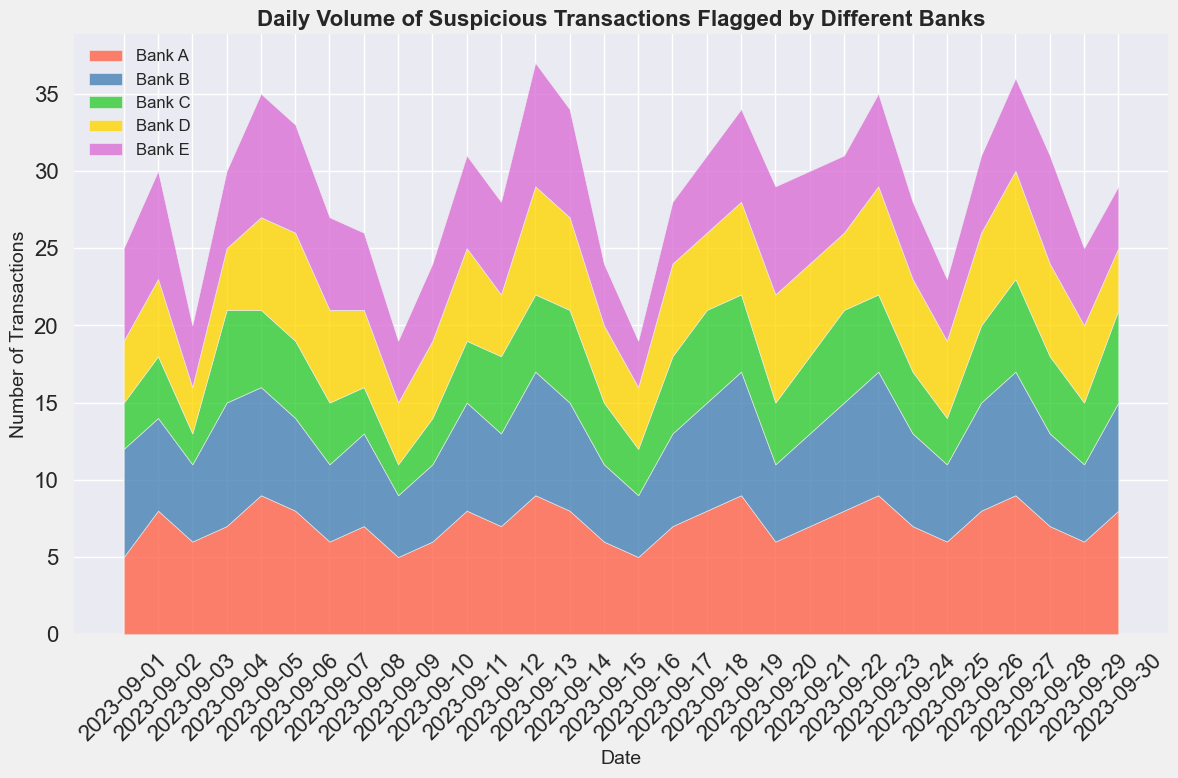What day did Bank C flag the highest number of suspicious transactions? Look at the area chart and identify the highest peak for Bank C, which corresponds to the tallest green section. Cross-reference this peak with the date on the x-axis directly below it.
Answer: 2023-09-04 On which date did Bank A flag more suspicious transactions than Bank E? Compare the height of Bank A's (red) and Bank E's (purple) sections on the area chart for each date. Identify the dates where the red area is taller than the purple area.
Answer: 2023-09-01, 2023-09-09, 2023-09-10, 2023-09-20 Which bank had the smallest number of flagged transactions on 2023-09-17? Note the stacked areas corresponding to each bank on 2023-09-17. The smallest area close to the x-axis pertains to the bank with the least flagged transactions.
Answer: Bank E What is the total number of suspicious transactions flagged on 2023-09-13? Calculate the height of the stack on 2023-09-13 by summing the individual contributions of all banks. This is found by visually adding the heights of red, blue, green, yellow, and purple sections.
Answer: 38 Compare the number of flagged transactions by Bank B and Bank D on 2023-09-09. Which one is higher? Observe the heights of Bank B's (blue) and Bank D's (yellow) sections on 2023-09-09. The taller section indicates which bank flagged more transactions.
Answer: Bank D Between 2023-09-15 and 2023-09-20, which bank showed the most consistent number of flagged transactions? Examine the area chart for the given period and observe which bank's area shows the least variation in height. This is indicated by the flattest section within the interval.
Answer: Bank C On which date did the combined transactions of Bank A and Bank B peak? Combine the areas of Bank A (red) and Bank B (blue) for each date and compare the sums. Identify the date where their combined height is the tallest.
Answer: 2023-09-19 Did any bank have exactly 7 flagged transactions on any date? If so, which bank and on which date? Look through the chart for sections where the height reaches 7 (provide a visual check at the specific point). Cross-reference with the date and bank.
Answer: Bank E on 2023-09-20 How many times did Bank D flag more than 5 suspicious transactions in September? Count the number of days where the height of Bank D's (yellow) section exceeds the '5' mark on the y-axis.
Answer: 10 